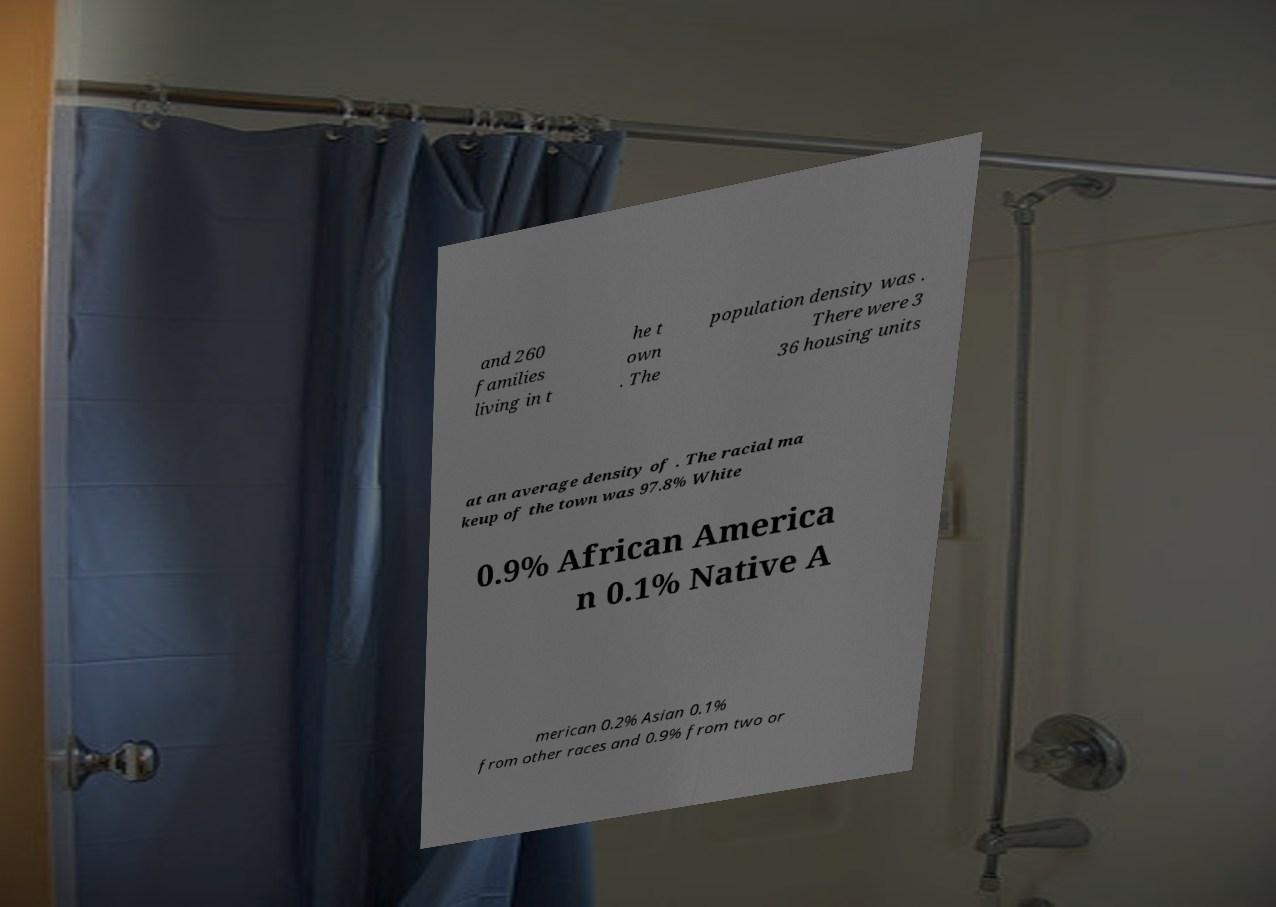For documentation purposes, I need the text within this image transcribed. Could you provide that? and 260 families living in t he t own . The population density was . There were 3 36 housing units at an average density of . The racial ma keup of the town was 97.8% White 0.9% African America n 0.1% Native A merican 0.2% Asian 0.1% from other races and 0.9% from two or 